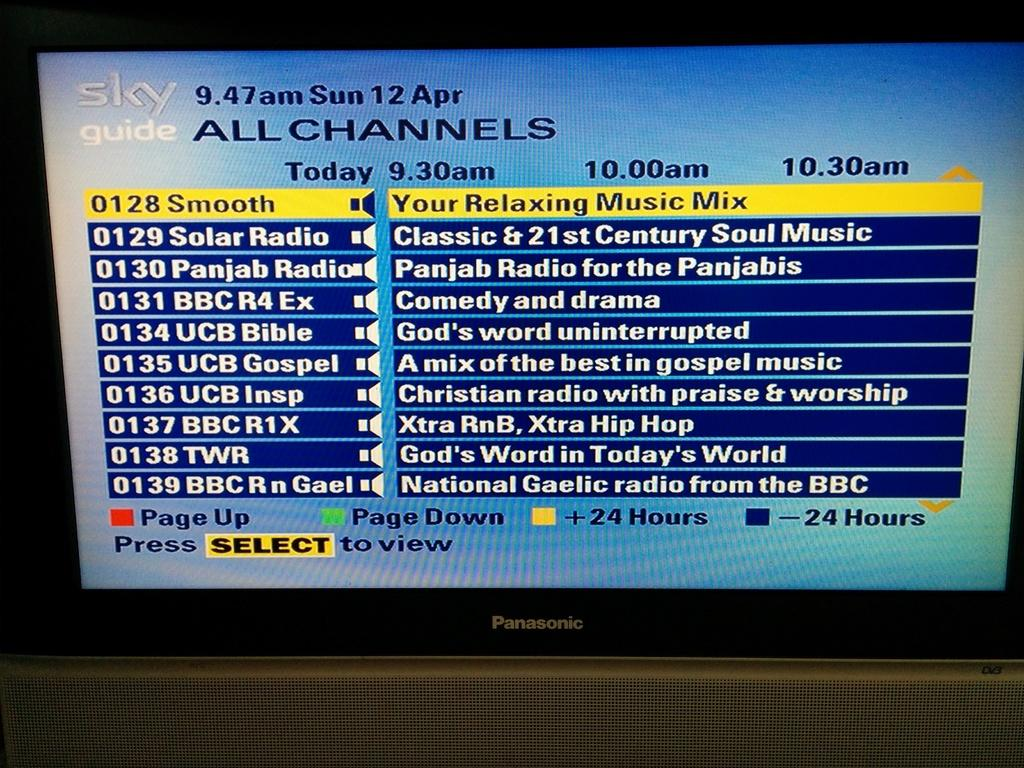Provide a one-sentence caption for the provided image. The television channel directory called Sky Guide is displayed on a Panasonic television set. 